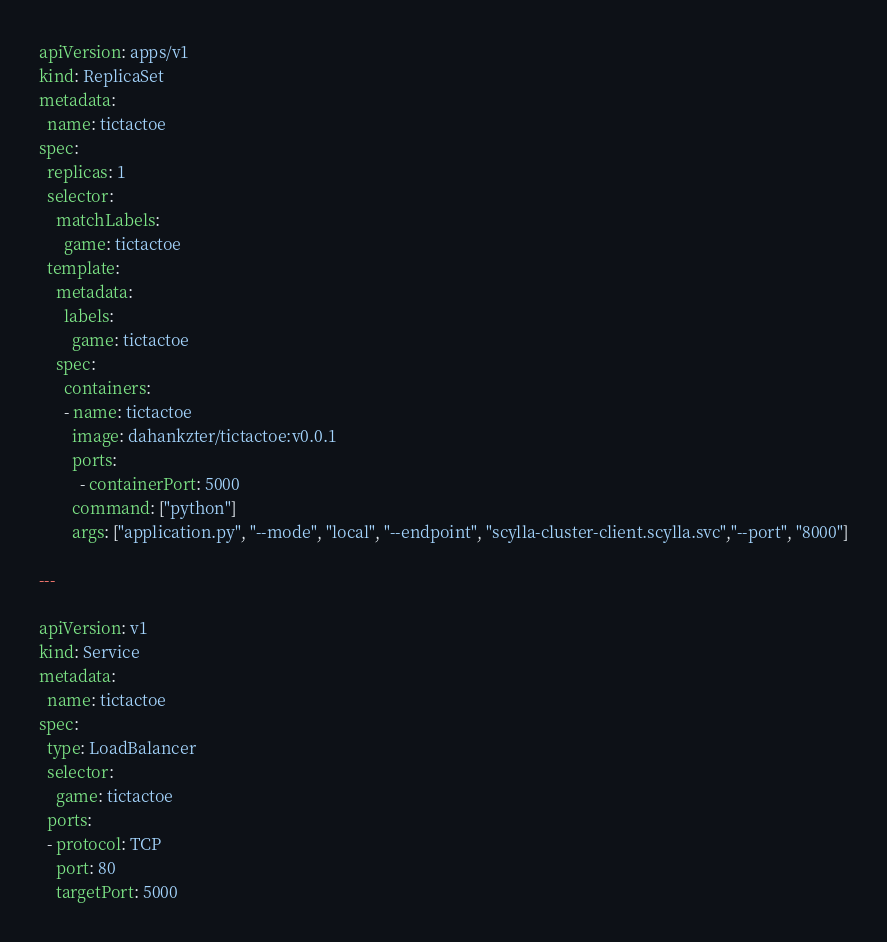<code> <loc_0><loc_0><loc_500><loc_500><_YAML_>apiVersion: apps/v1
kind: ReplicaSet
metadata:
  name: tictactoe
spec:
  replicas: 1
  selector:
    matchLabels:
      game: tictactoe
  template:
    metadata:
      labels:
        game: tictactoe
    spec:
      containers:
      - name: tictactoe
        image: dahankzter/tictactoe:v0.0.1
        ports:
          - containerPort: 5000
        command: ["python"]
        args: ["application.py", "--mode", "local", "--endpoint", "scylla-cluster-client.scylla.svc","--port", "8000"]

---

apiVersion: v1
kind: Service
metadata:
  name: tictactoe
spec:
  type: LoadBalancer
  selector:
    game: tictactoe
  ports:
  - protocol: TCP
    port: 80
    targetPort: 5000
</code> 